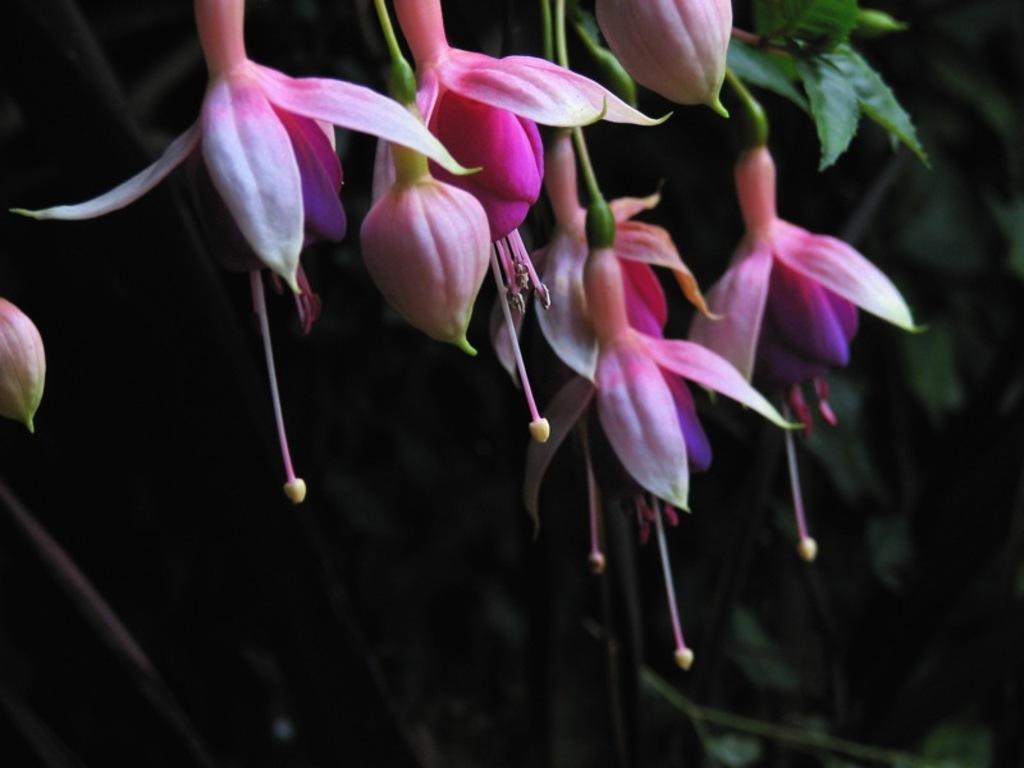In one or two sentences, can you explain what this image depicts? At the top of this image there are few flowers and buds. In the background few leaves are visible. 